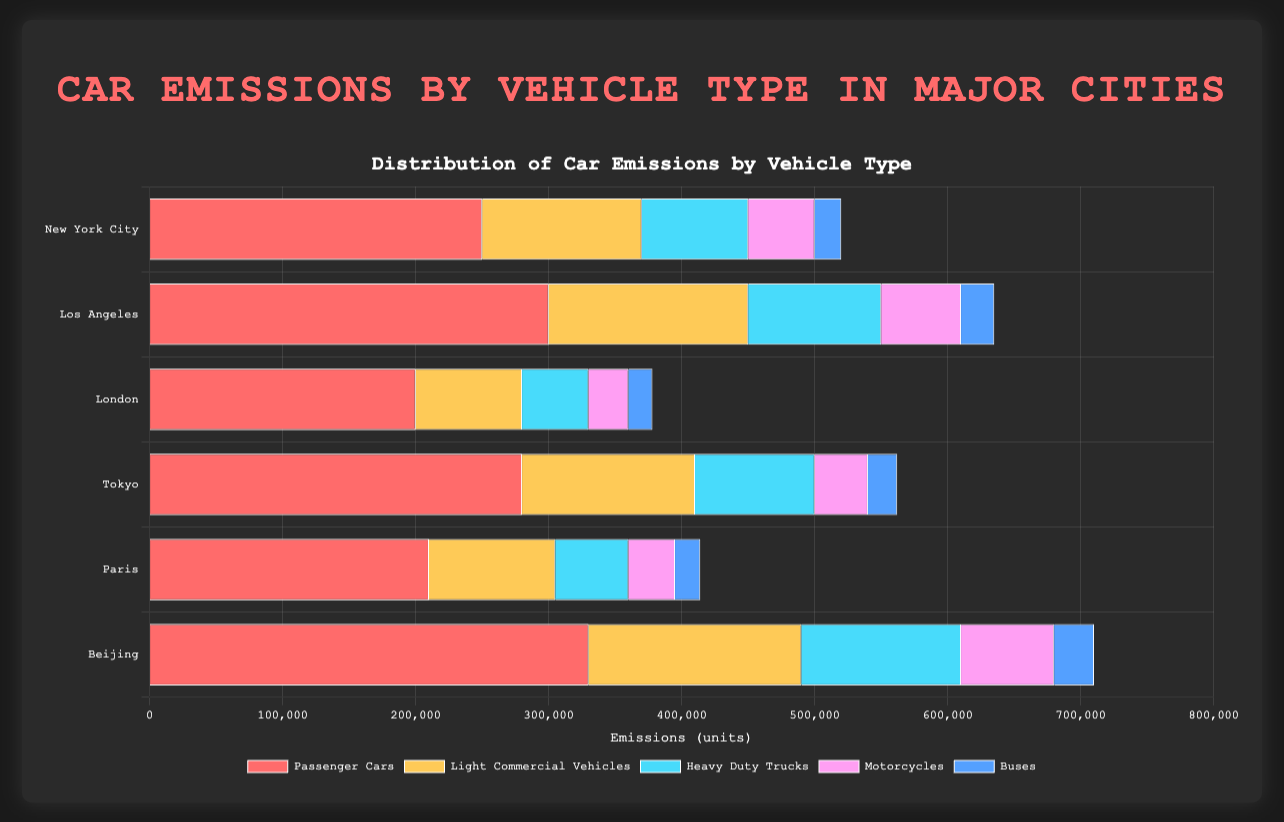Which city has the highest car emissions from motorcycles? From the figure, look for the bar representing motorcycles and identify which city has the longest bar for that category. That city is Beijing.
Answer: Beijing What is the total car emissions for New York City? Sum up the emissions for each vehicle type in New York City: (250000 for Passenger Cars) + (120000 for Light Commercial Vehicles) + (80000 for Heavy Duty Trucks) + (50000 for Motorcycles) + (20000 for Buses) = 520000.
Answer: 520000 Which vehicle type has the highest emissions in Tokyo? Look at the bars for each vehicle type in Tokyo and identify the longest bar. Passenger Cars have the longest bar.
Answer: Passenger Cars Compare the emissions from buses between London and Paris. Which one is greater? Look at the bars for buses in both London and Paris and compare their lengths. The bar for London has 18000 and Paris has 19000, so Paris is greater.
Answer: Paris What is the difference in emissions from heavy-duty trucks between Los Angeles and Paris? Subtract the emissions of heavy-duty trucks in Paris (55000) from those in Los Angeles (100000). 100000 - 55000 = 45000.
Answer: 45000 Which city has the lowest total car emissions? Calculate the sum of emissions for each city and identify the city with the lowest total. The sums are: New York City (520000), Los Angeles (635000), London (378000), Tokyo (562000), Paris (414000), and Beijing (710000). London has the lowest total.
Answer: London How do the emissions from light commercial vehicles compare between New York City and Tokyo? Compare the bars representing light commercial vehicles for New York City and Tokyo and see which one is longer. Tokyo has 130000 and New York City has 120000, so Tokyo is greater.
Answer: Tokyo What is the average emissions from motorcycles in all cities? Sum up the emissions from motorcycles across all cities and divide by the number of cities. The sum is (50000 + 60000 + 30000 + 40000 + 35000 + 70000) = 285000. There are 6 cities, so the average is 285000 / 6 = 47500.
Answer: 47500 By how much do the emissions from passenger cars in Beijing exceed those in Paris? Subtract the emissions of passenger cars in Paris (210000) from those in Beijing (330000). 330000 - 210000 = 120000.
Answer: 120000 